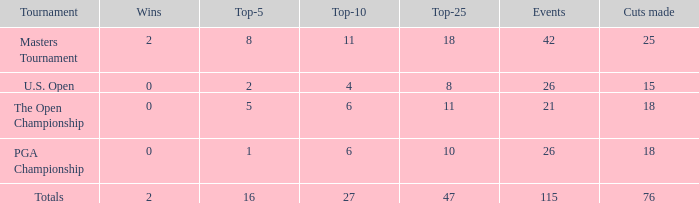What is the overall number of wins with 76 cuts made and events exceeding 115? None. 